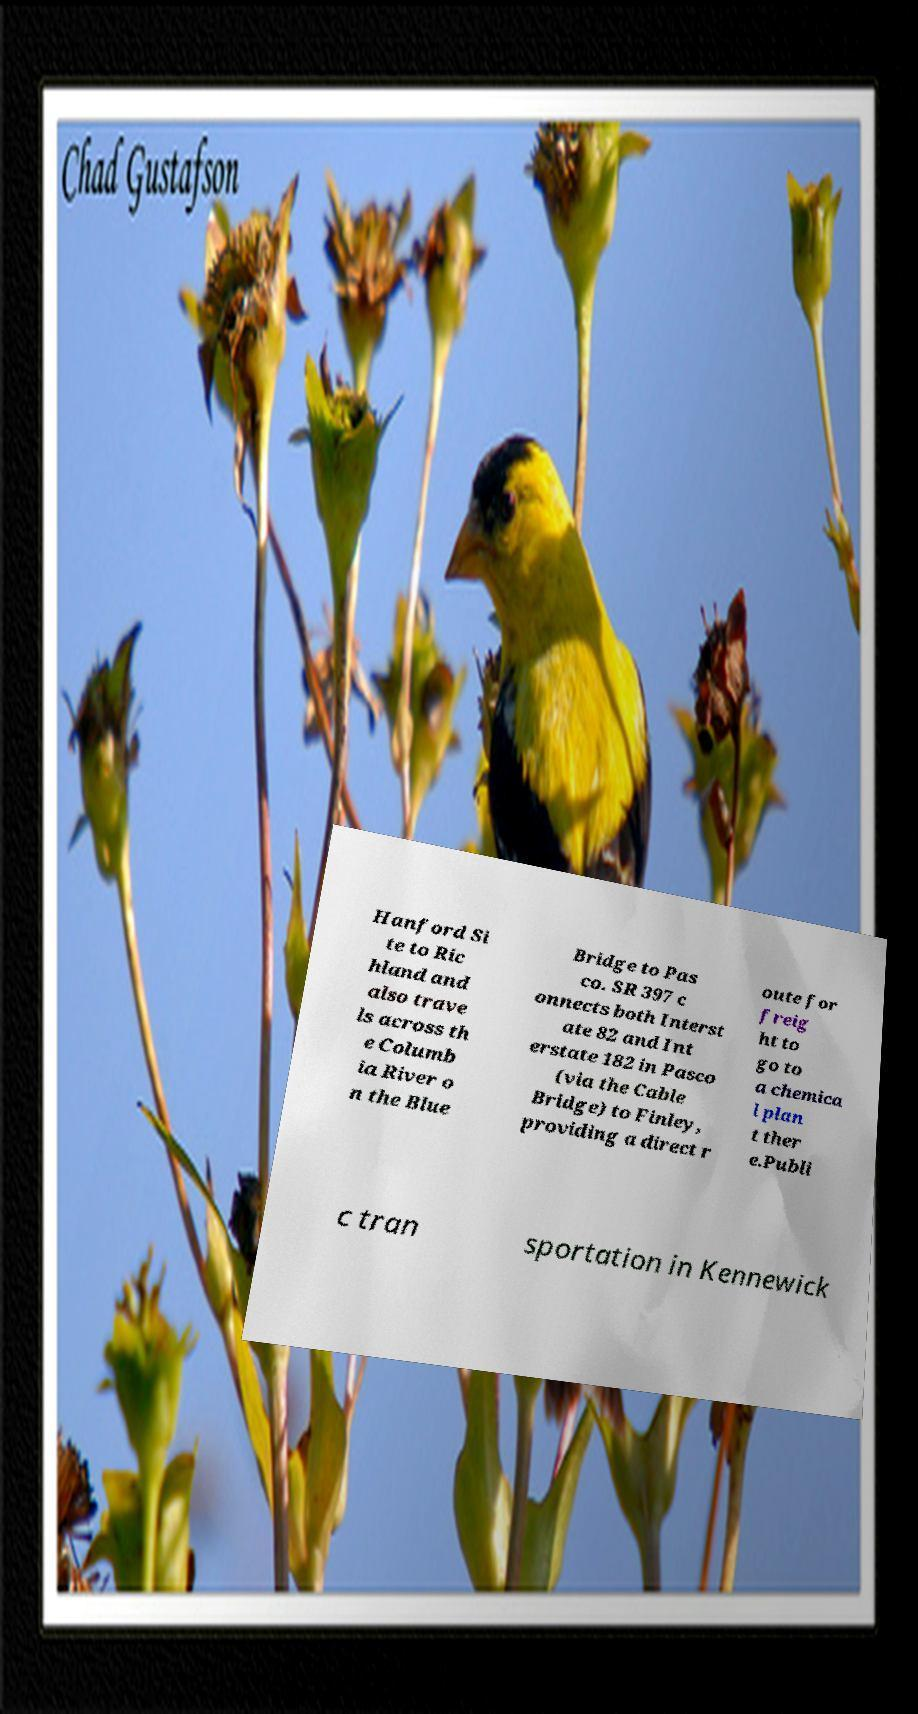Please read and relay the text visible in this image. What does it say? Hanford Si te to Ric hland and also trave ls across th e Columb ia River o n the Blue Bridge to Pas co. SR 397 c onnects both Interst ate 82 and Int erstate 182 in Pasco (via the Cable Bridge) to Finley, providing a direct r oute for freig ht to go to a chemica l plan t ther e.Publi c tran sportation in Kennewick 